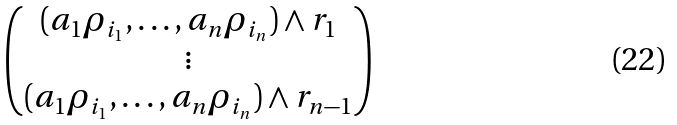Convert formula to latex. <formula><loc_0><loc_0><loc_500><loc_500>\begin{pmatrix} ( a _ { 1 } \rho _ { i _ { 1 } } , \dots , a _ { n } \rho _ { i _ { n } } ) \wedge r _ { 1 } \\ \vdots \\ ( a _ { 1 } \rho _ { i _ { 1 } } , \dots , a _ { n } \rho _ { i _ { n } } ) \wedge r _ { n - 1 } \end{pmatrix}</formula> 